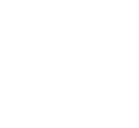<formula> <loc_0><loc_0><loc_500><loc_500>\begin{smallmatrix} 2 & 1 & 1 & 1 & 1 & 1 & 1 \\ 1 & 2 & 1 & 1 & 1 & 1 & 1 \\ 1 & 1 & 3 & 1 & 1 & 1 & 1 \\ 1 & 1 & 1 & 3 & 1 & 1 & 0 \\ 1 & 1 & 1 & 1 & 3 & 0 & 0 \\ 1 & 1 & 1 & 1 & 0 & 3 & 0 \\ 1 & 1 & 1 & 0 & 0 & 0 & 3 \end{smallmatrix}</formula> 